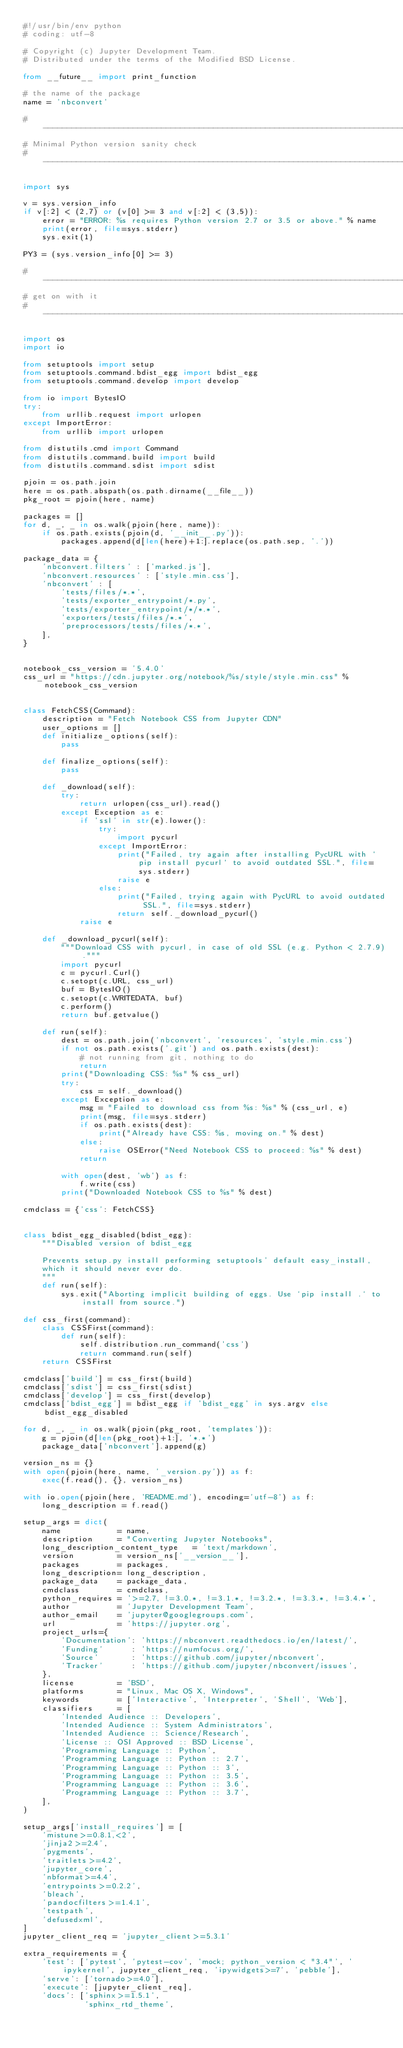<code> <loc_0><loc_0><loc_500><loc_500><_Python_>#!/usr/bin/env python
# coding: utf-8

# Copyright (c) Jupyter Development Team.
# Distributed under the terms of the Modified BSD License.

from __future__ import print_function

# the name of the package
name = 'nbconvert'

#-----------------------------------------------------------------------------
# Minimal Python version sanity check
#-----------------------------------------------------------------------------

import sys

v = sys.version_info
if v[:2] < (2,7) or (v[0] >= 3 and v[:2] < (3,5)):
    error = "ERROR: %s requires Python version 2.7 or 3.5 or above." % name
    print(error, file=sys.stderr)
    sys.exit(1)

PY3 = (sys.version_info[0] >= 3)

#-----------------------------------------------------------------------------
# get on with it
#-----------------------------------------------------------------------------

import os
import io

from setuptools import setup
from setuptools.command.bdist_egg import bdist_egg
from setuptools.command.develop import develop

from io import BytesIO
try:
    from urllib.request import urlopen
except ImportError:
    from urllib import urlopen

from distutils.cmd import Command
from distutils.command.build import build
from distutils.command.sdist import sdist

pjoin = os.path.join
here = os.path.abspath(os.path.dirname(__file__))
pkg_root = pjoin(here, name)

packages = []
for d, _, _ in os.walk(pjoin(here, name)):
    if os.path.exists(pjoin(d, '__init__.py')):
        packages.append(d[len(here)+1:].replace(os.path.sep, '.'))

package_data = {
    'nbconvert.filters' : ['marked.js'],
    'nbconvert.resources' : ['style.min.css'],
    'nbconvert' : [
        'tests/files/*.*',
        'tests/exporter_entrypoint/*.py',
        'tests/exporter_entrypoint/*/*.*',
        'exporters/tests/files/*.*',
        'preprocessors/tests/files/*.*',
    ],
}


notebook_css_version = '5.4.0'
css_url = "https://cdn.jupyter.org/notebook/%s/style/style.min.css" % notebook_css_version


class FetchCSS(Command):
    description = "Fetch Notebook CSS from Jupyter CDN"
    user_options = []
    def initialize_options(self):
        pass

    def finalize_options(self):
        pass

    def _download(self):
        try:
            return urlopen(css_url).read()
        except Exception as e:
            if 'ssl' in str(e).lower():
                try:
                    import pycurl
                except ImportError:
                    print("Failed, try again after installing PycURL with `pip install pycurl` to avoid outdated SSL.", file=sys.stderr)
                    raise e
                else:
                    print("Failed, trying again with PycURL to avoid outdated SSL.", file=sys.stderr)
                    return self._download_pycurl()
            raise e

    def _download_pycurl(self):
        """Download CSS with pycurl, in case of old SSL (e.g. Python < 2.7.9)."""
        import pycurl
        c = pycurl.Curl()
        c.setopt(c.URL, css_url)
        buf = BytesIO()
        c.setopt(c.WRITEDATA, buf)
        c.perform()
        return buf.getvalue()

    def run(self):
        dest = os.path.join('nbconvert', 'resources', 'style.min.css')
        if not os.path.exists('.git') and os.path.exists(dest):
            # not running from git, nothing to do
            return
        print("Downloading CSS: %s" % css_url)
        try:
            css = self._download()
        except Exception as e:
            msg = "Failed to download css from %s: %s" % (css_url, e)
            print(msg, file=sys.stderr)
            if os.path.exists(dest):
                print("Already have CSS: %s, moving on." % dest)
            else:
                raise OSError("Need Notebook CSS to proceed: %s" % dest)
            return

        with open(dest, 'wb') as f:
            f.write(css)
        print("Downloaded Notebook CSS to %s" % dest)

cmdclass = {'css': FetchCSS}


class bdist_egg_disabled(bdist_egg):
    """Disabled version of bdist_egg

    Prevents setup.py install performing setuptools' default easy_install,
    which it should never ever do.
    """
    def run(self):
        sys.exit("Aborting implicit building of eggs. Use `pip install .` to install from source.")

def css_first(command):
    class CSSFirst(command):
        def run(self):
            self.distribution.run_command('css')
            return command.run(self)
    return CSSFirst

cmdclass['build'] = css_first(build)
cmdclass['sdist'] = css_first(sdist)
cmdclass['develop'] = css_first(develop)
cmdclass['bdist_egg'] = bdist_egg if 'bdist_egg' in sys.argv else bdist_egg_disabled

for d, _, _ in os.walk(pjoin(pkg_root, 'templates')):
    g = pjoin(d[len(pkg_root)+1:], '*.*')
    package_data['nbconvert'].append(g)

version_ns = {}
with open(pjoin(here, name, '_version.py')) as f:
    exec(f.read(), {}, version_ns)

with io.open(pjoin(here, 'README.md'), encoding='utf-8') as f:
    long_description = f.read()

setup_args = dict(
    name            = name,
    description     = "Converting Jupyter Notebooks",
    long_description_content_type   = 'text/markdown',
    version         = version_ns['__version__'],
    packages        = packages,
    long_description= long_description,
    package_data    = package_data,
    cmdclass        = cmdclass,
    python_requires = '>=2.7, !=3.0.*, !=3.1.*, !=3.2.*, !=3.3.*, !=3.4.*',
    author          = 'Jupyter Development Team',
    author_email    = 'jupyter@googlegroups.com',
    url             = 'https://jupyter.org',
    project_urls={
        'Documentation': 'https://nbconvert.readthedocs.io/en/latest/',
        'Funding'      : 'https://numfocus.org/',
        'Source'       : 'https://github.com/jupyter/nbconvert',
        'Tracker'      : 'https://github.com/jupyter/nbconvert/issues',
    },
    license         = 'BSD',
    platforms       = "Linux, Mac OS X, Windows",
    keywords        = ['Interactive', 'Interpreter', 'Shell', 'Web'],
    classifiers     = [
        'Intended Audience :: Developers',
        'Intended Audience :: System Administrators',
        'Intended Audience :: Science/Research',
        'License :: OSI Approved :: BSD License',
        'Programming Language :: Python',
        'Programming Language :: Python :: 2.7',
        'Programming Language :: Python :: 3',
        'Programming Language :: Python :: 3.5',
        'Programming Language :: Python :: 3.6',
        'Programming Language :: Python :: 3.7',
    ],
)

setup_args['install_requires'] = [
    'mistune>=0.8.1,<2',
    'jinja2>=2.4',
    'pygments',
    'traitlets>=4.2',
    'jupyter_core',
    'nbformat>=4.4',
    'entrypoints>=0.2.2',
    'bleach',
    'pandocfilters>=1.4.1',
    'testpath',
    'defusedxml',
]
jupyter_client_req = 'jupyter_client>=5.3.1'

extra_requirements = {
    'test': ['pytest', 'pytest-cov', 'mock; python_version < "3.4"', 'ipykernel', jupyter_client_req, 'ipywidgets>=7', 'pebble'],
    'serve': ['tornado>=4.0'],
    'execute': [jupyter_client_req],
    'docs': ['sphinx>=1.5.1',
             'sphinx_rtd_theme',</code> 